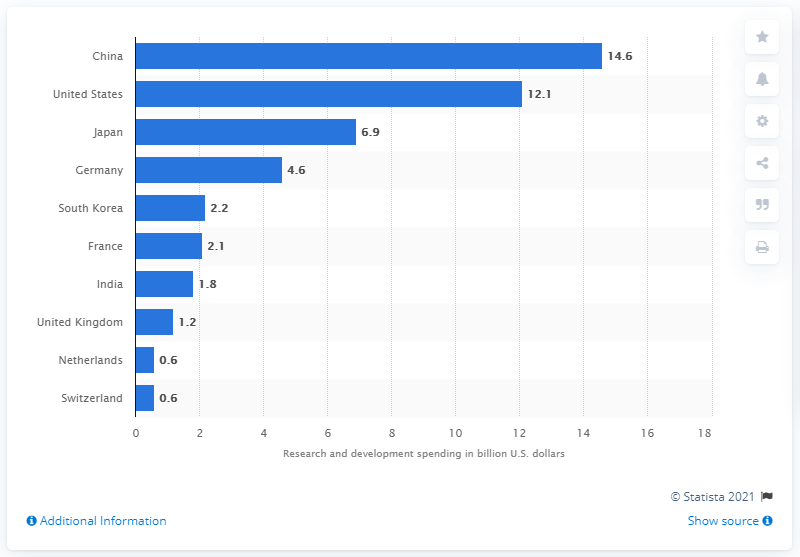Give some essential details in this illustration. According to a recent study, China had the highest R&D spending in the global chemical industry in 2017, surpassing all other countries in terms of investment in research and development. In 2017, the United States spent 12.1% of its total budget on research and development. 